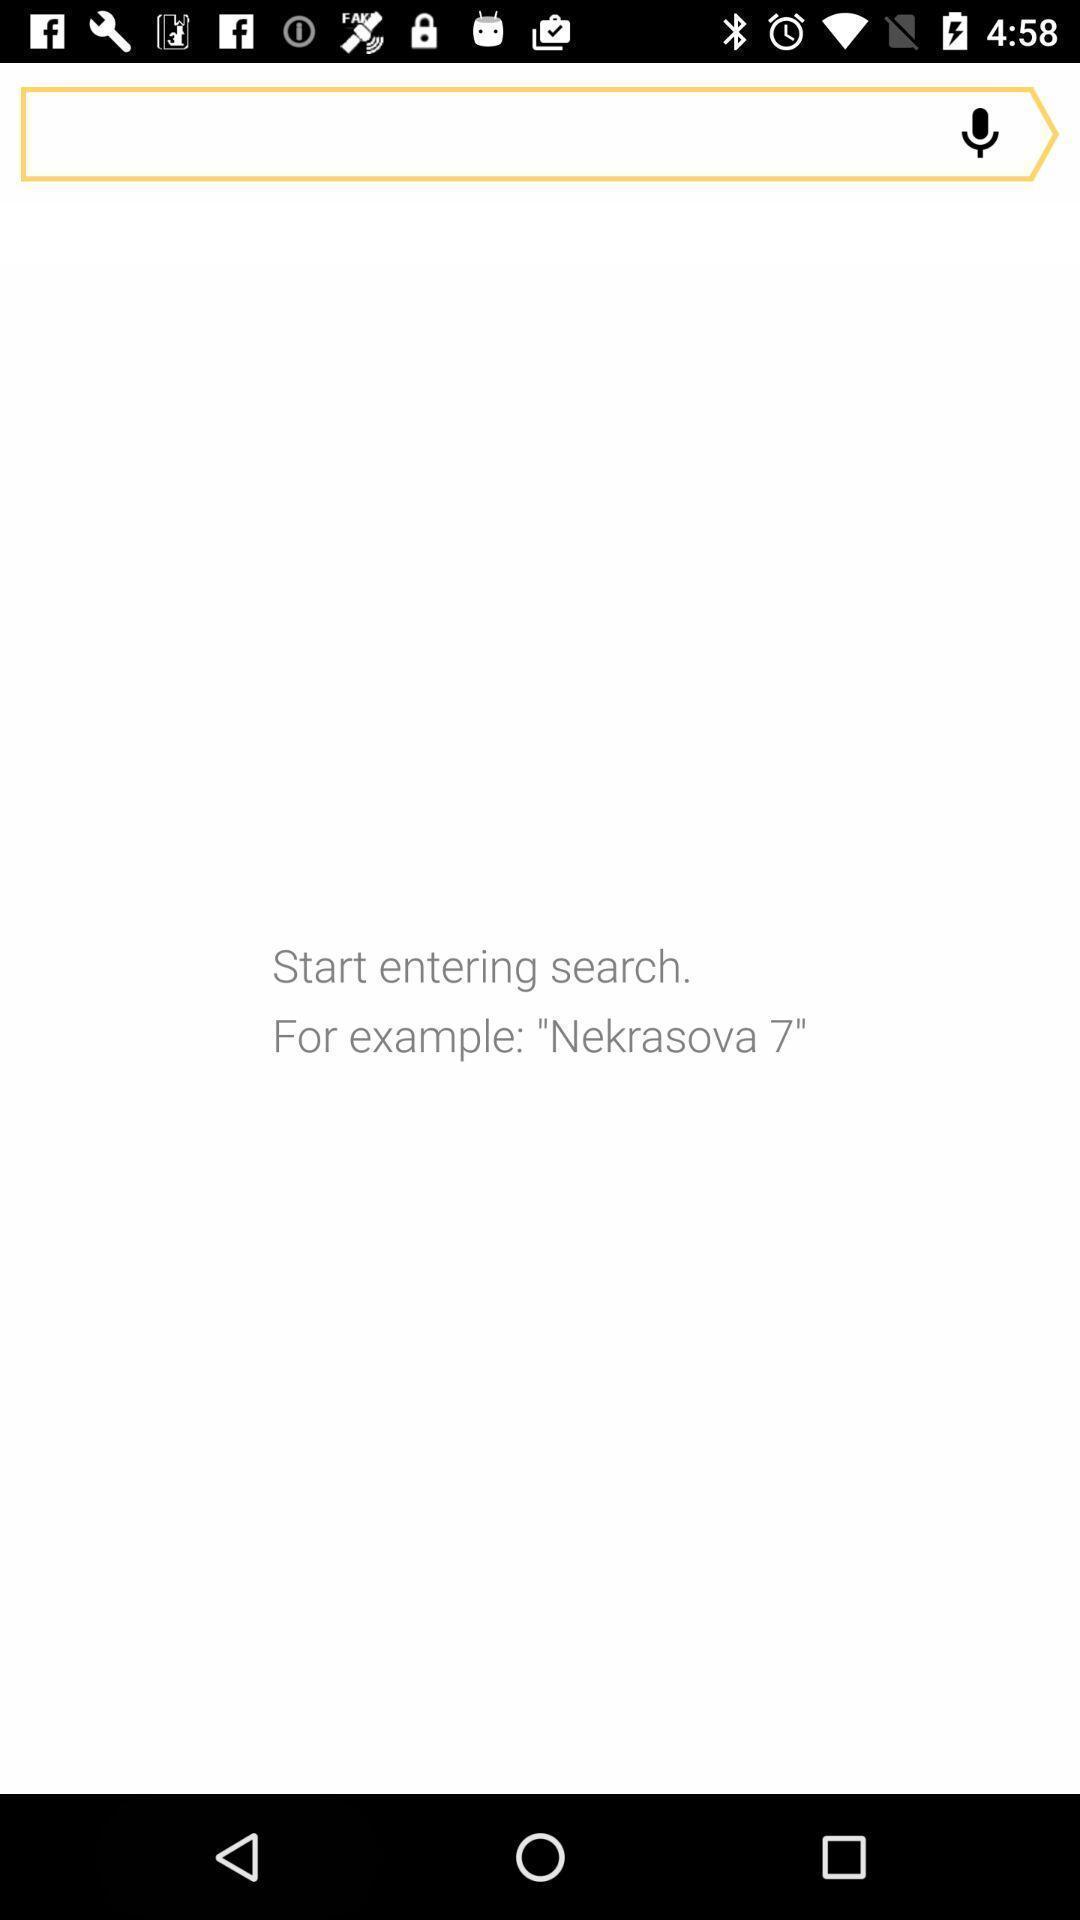Explain the elements present in this screenshot. Screen displaying a search bar and a microphone icon. 